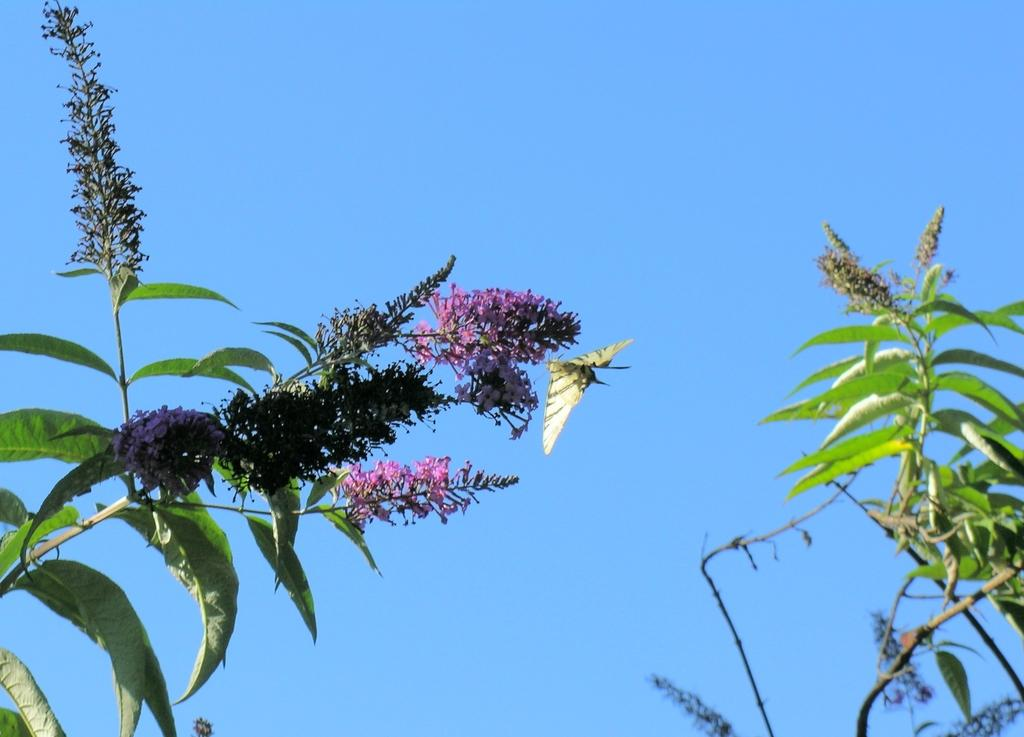What type of vegetation can be seen in the image? There are leaves and flowers in the image. What color are the flowers in the image? The flowers are pink in color. What can be seen in the background of the image? The sky is visible in the background of the image. How is the sky in the image? The sky is clear in the image. What type of powder is being used by the committee in the image? There is no committee or powder present in the image. What type of work is being done by the flowers in the image? The flowers are not performing any work in the image; they are simply being depicted as part of the natural scene. 